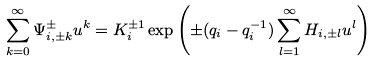<formula> <loc_0><loc_0><loc_500><loc_500>\sum _ { k = 0 } ^ { \infty } \Psi ^ { \pm } _ { i , \pm k } u ^ { k } = K ^ { \pm 1 } _ { i } \exp \left ( \pm ( q _ { i } - q ^ { - 1 } _ { i } ) \sum _ { l = 1 } ^ { \infty } H _ { i , \pm l } u ^ { l } \right )</formula> 